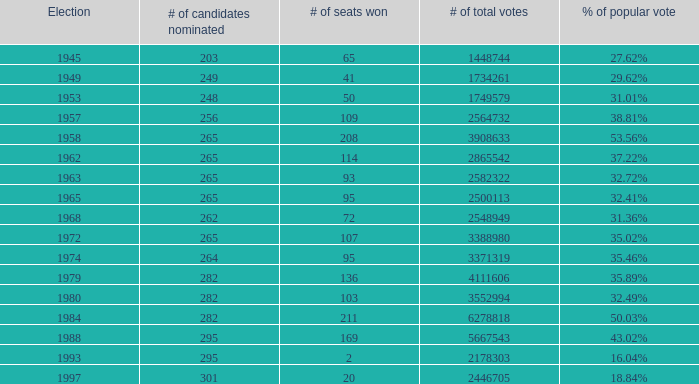Would you be able to parse every entry in this table? {'header': ['Election', '# of candidates nominated', '# of seats won', '# of total votes', '% of popular vote'], 'rows': [['1945', '203', '65', '1448744', '27.62%'], ['1949', '249', '41', '1734261', '29.62%'], ['1953', '248', '50', '1749579', '31.01%'], ['1957', '256', '109', '2564732', '38.81%'], ['1958', '265', '208', '3908633', '53.56%'], ['1962', '265', '114', '2865542', '37.22%'], ['1963', '265', '93', '2582322', '32.72%'], ['1965', '265', '95', '2500113', '32.41%'], ['1968', '262', '72', '2548949', '31.36%'], ['1972', '265', '107', '3388980', '35.02%'], ['1974', '264', '95', '3371319', '35.46%'], ['1979', '282', '136', '4111606', '35.89%'], ['1980', '282', '103', '3552994', '32.49%'], ['1984', '282', '211', '6278818', '50.03%'], ['1988', '295', '169', '5667543', '43.02%'], ['1993', '295', '2', '2178303', '16.04%'], ['1997', '301', '20', '2446705', '18.84%']]} What is the election year when the # of candidates nominated was 262? 1.0. 